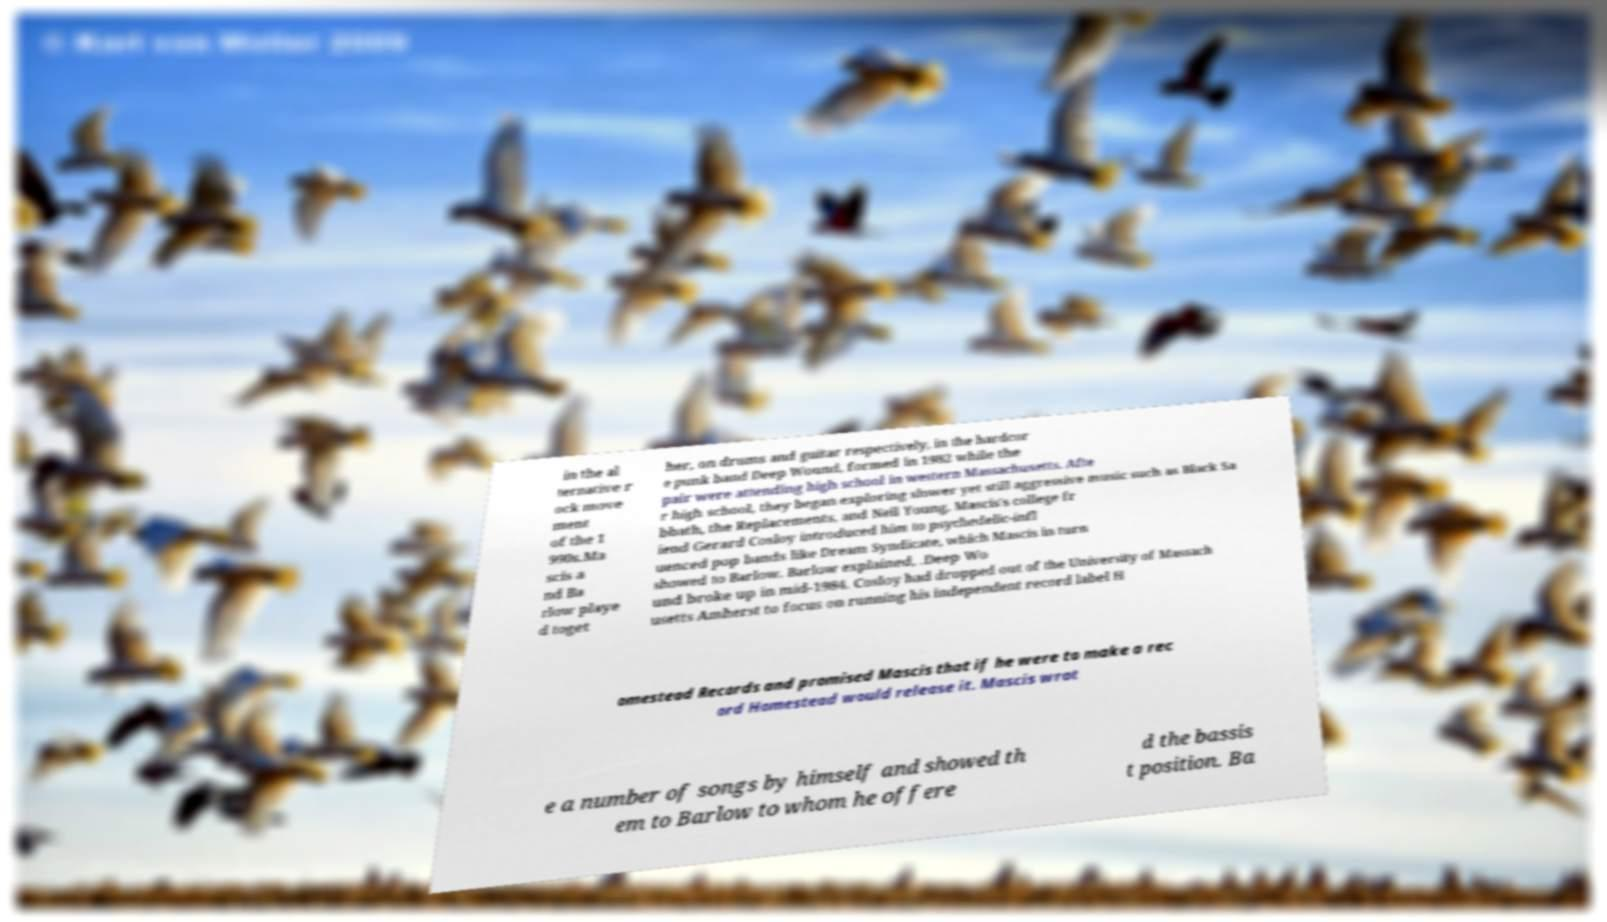For documentation purposes, I need the text within this image transcribed. Could you provide that? in the al ternative r ock move ment of the 1 990s.Ma scis a nd Ba rlow playe d toget her, on drums and guitar respectively, in the hardcor e punk band Deep Wound, formed in 1982 while the pair were attending high school in western Massachusetts. Afte r high school, they began exploring slower yet still aggressive music such as Black Sa bbath, the Replacements, and Neil Young. Mascis's college fr iend Gerard Cosloy introduced him to psychedelic-infl uenced pop bands like Dream Syndicate, which Mascis in turn showed to Barlow. Barlow explained, .Deep Wo und broke up in mid-1984. Cosloy had dropped out of the University of Massach usetts Amherst to focus on running his independent record label H omestead Records and promised Mascis that if he were to make a rec ord Homestead would release it. Mascis wrot e a number of songs by himself and showed th em to Barlow to whom he offere d the bassis t position. Ba 